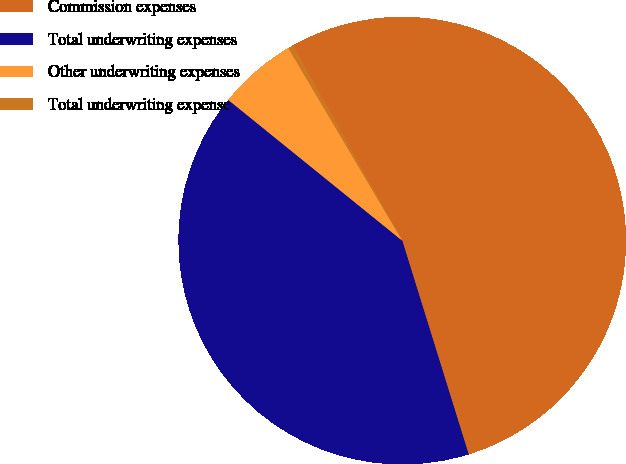Convert chart to OTSL. <chart><loc_0><loc_0><loc_500><loc_500><pie_chart><fcel>Commission expenses<fcel>Total underwriting expenses<fcel>Other underwriting expenses<fcel>Total underwriting expense<nl><fcel>53.32%<fcel>40.62%<fcel>5.67%<fcel>0.38%<nl></chart> 